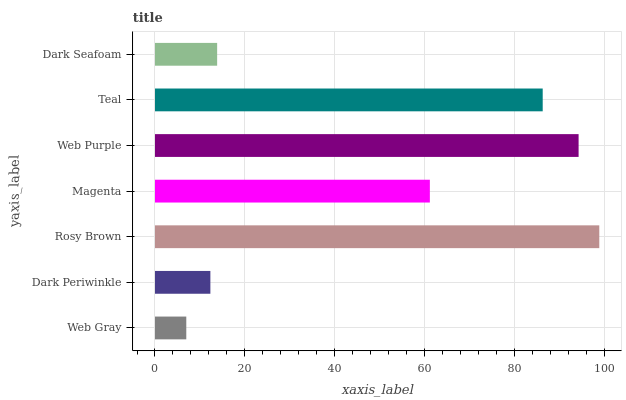Is Web Gray the minimum?
Answer yes or no. Yes. Is Rosy Brown the maximum?
Answer yes or no. Yes. Is Dark Periwinkle the minimum?
Answer yes or no. No. Is Dark Periwinkle the maximum?
Answer yes or no. No. Is Dark Periwinkle greater than Web Gray?
Answer yes or no. Yes. Is Web Gray less than Dark Periwinkle?
Answer yes or no. Yes. Is Web Gray greater than Dark Periwinkle?
Answer yes or no. No. Is Dark Periwinkle less than Web Gray?
Answer yes or no. No. Is Magenta the high median?
Answer yes or no. Yes. Is Magenta the low median?
Answer yes or no. Yes. Is Rosy Brown the high median?
Answer yes or no. No. Is Rosy Brown the low median?
Answer yes or no. No. 